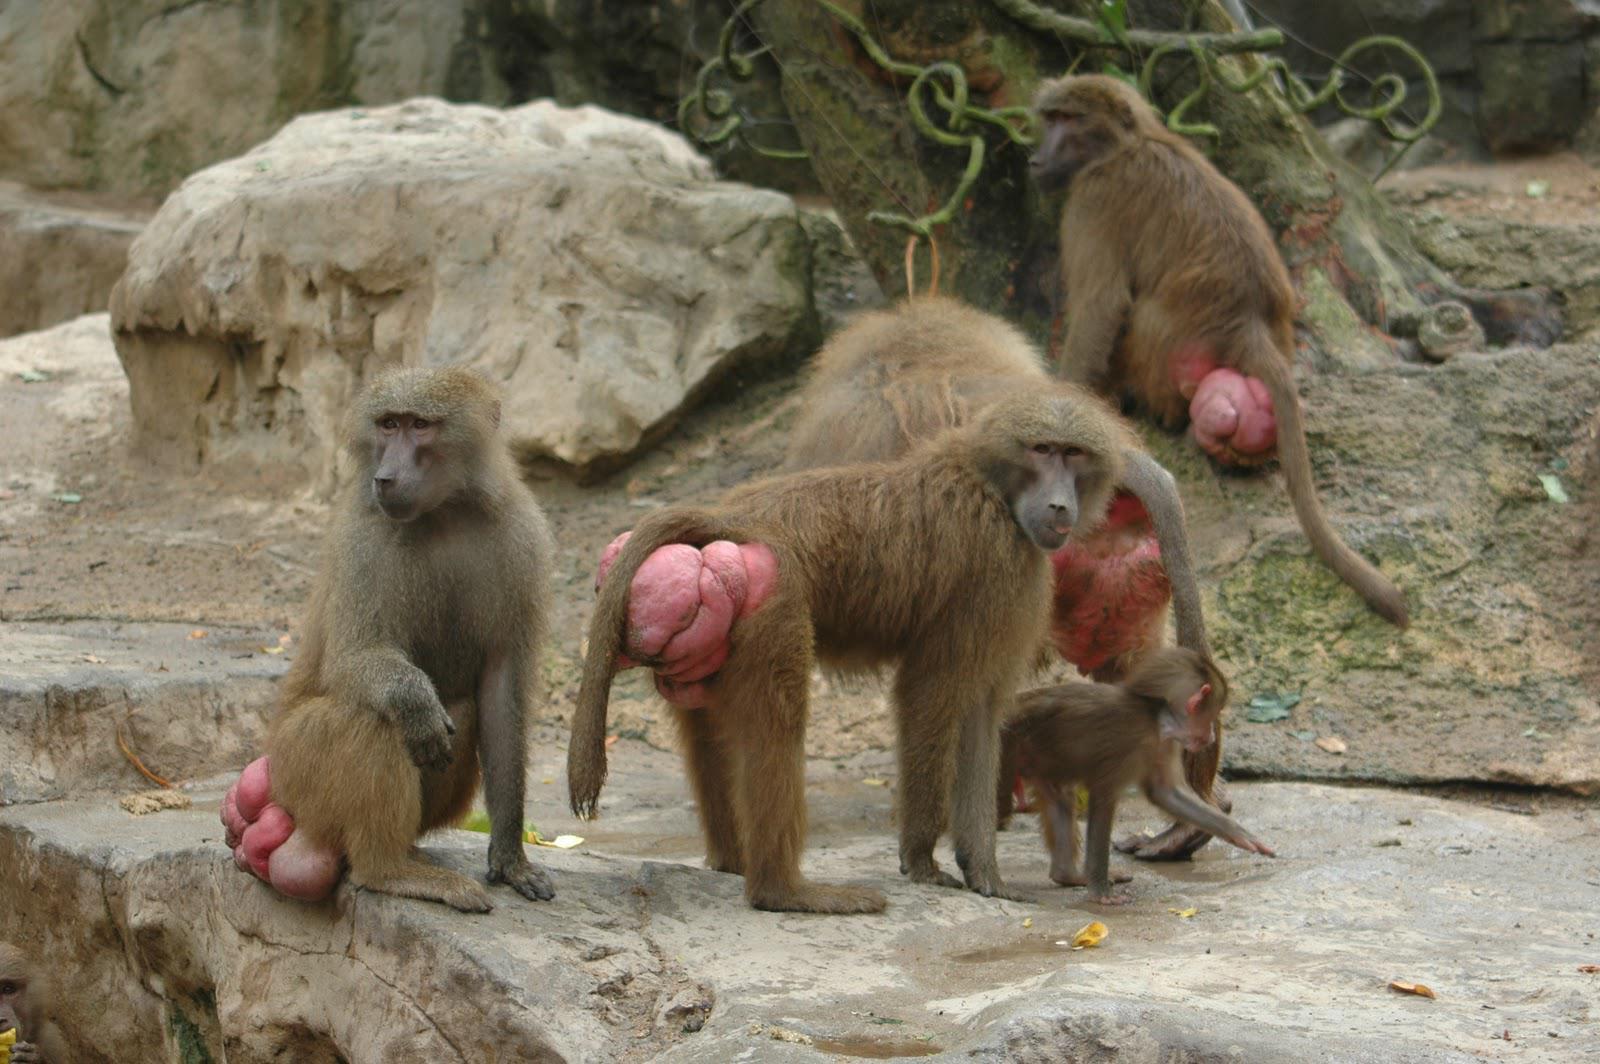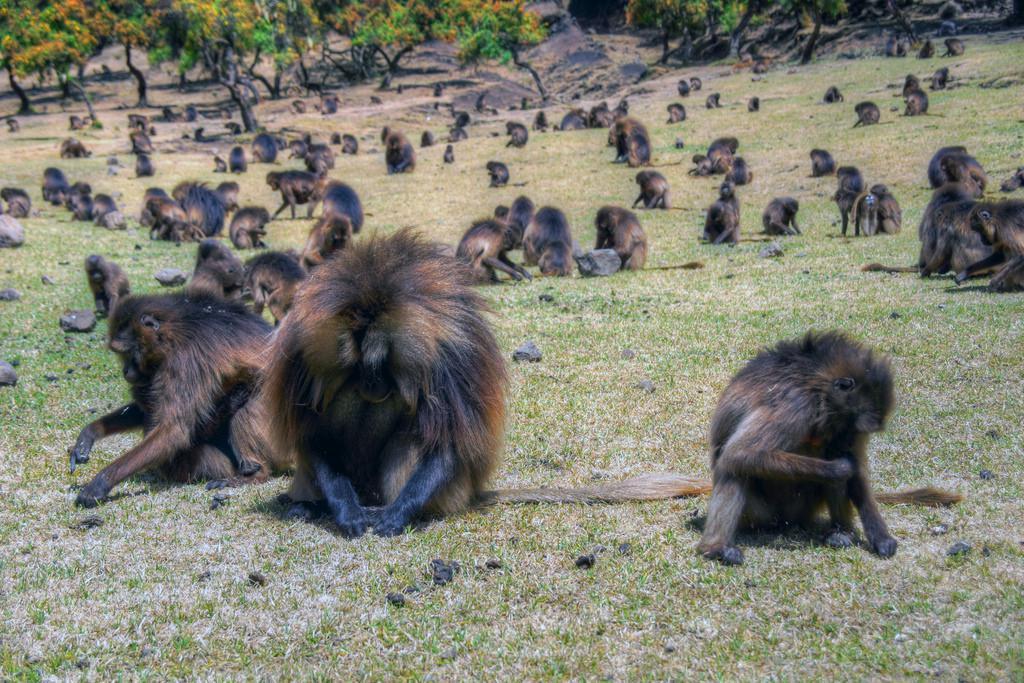The first image is the image on the left, the second image is the image on the right. Analyze the images presented: Is the assertion "The combined images include no more than ten baboons and include at least two baby baboons." valid? Answer yes or no. No. The first image is the image on the left, the second image is the image on the right. Examine the images to the left and right. Is the description "There are exactly seven monkeys." accurate? Answer yes or no. No. 